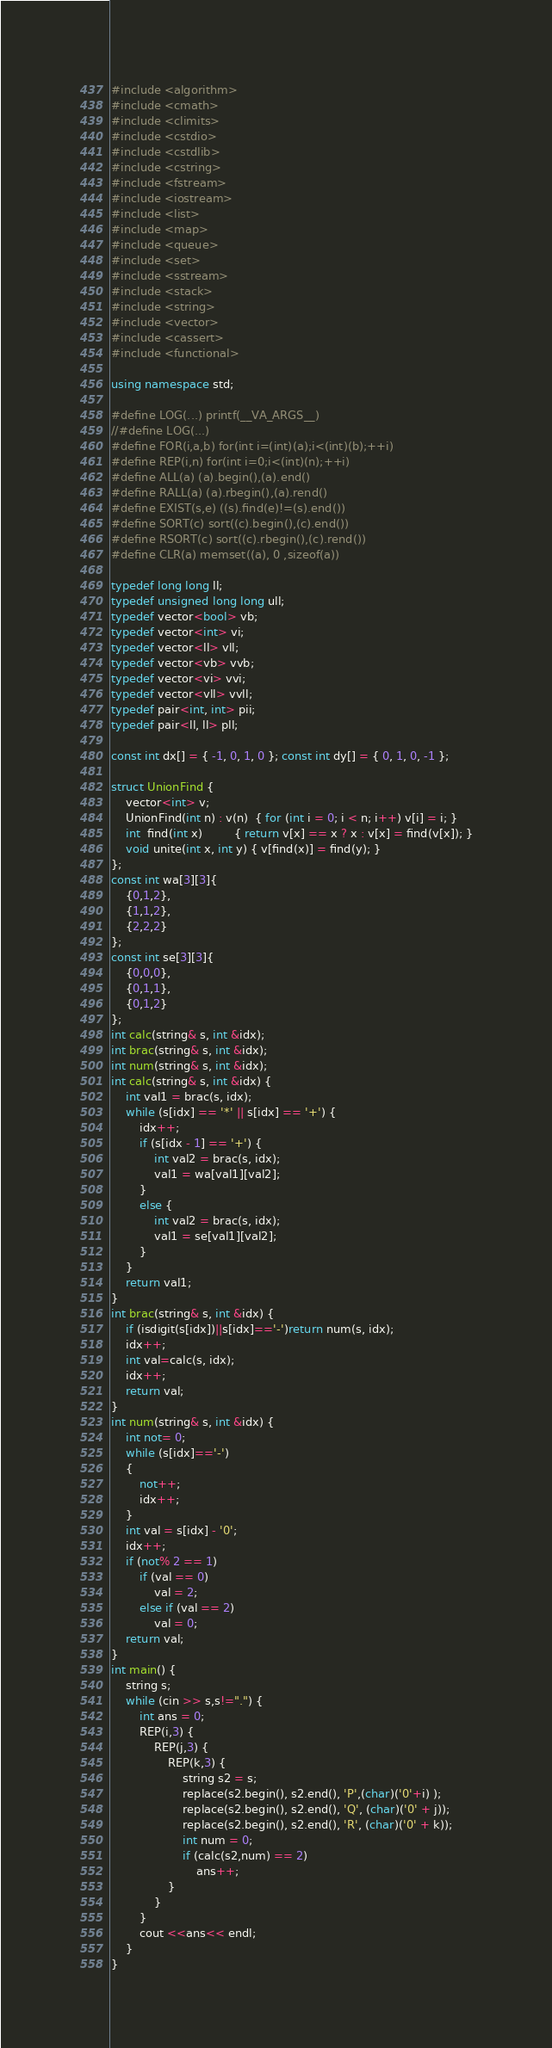<code> <loc_0><loc_0><loc_500><loc_500><_C++_>#include <algorithm>
#include <cmath>
#include <climits>
#include <cstdio>
#include <cstdlib>
#include <cstring>
#include <fstream>
#include <iostream>
#include <list>
#include <map>
#include <queue>
#include <set>
#include <sstream>
#include <stack>
#include <string>
#include <vector>
#include <cassert>
#include <functional>

using namespace std;

#define LOG(...) printf(__VA_ARGS__)
//#define LOG(...)
#define FOR(i,a,b) for(int i=(int)(a);i<(int)(b);++i)
#define REP(i,n) for(int i=0;i<(int)(n);++i)
#define ALL(a) (a).begin(),(a).end()
#define RALL(a) (a).rbegin(),(a).rend()
#define EXIST(s,e) ((s).find(e)!=(s).end())
#define SORT(c) sort((c).begin(),(c).end())
#define RSORT(c) sort((c).rbegin(),(c).rend())
#define CLR(a) memset((a), 0 ,sizeof(a))

typedef long long ll;
typedef unsigned long long ull;
typedef vector<bool> vb;
typedef vector<int> vi;
typedef vector<ll> vll;
typedef vector<vb> vvb;
typedef vector<vi> vvi;
typedef vector<vll> vvll;
typedef pair<int, int> pii;
typedef pair<ll, ll> pll;

const int dx[] = { -1, 0, 1, 0 }; const int dy[] = { 0, 1, 0, -1 };

struct UnionFind {
	vector<int> v;
	UnionFind(int n) : v(n)  { for (int i = 0; i < n; i++) v[i] = i; }
	int  find(int x)         { return v[x] == x ? x : v[x] = find(v[x]); }
	void unite(int x, int y) { v[find(x)] = find(y); }
};
const int wa[3][3]{
	{0,1,2},
	{1,1,2},
	{2,2,2}
};
const int se[3][3]{
	{0,0,0},
	{0,1,1},
	{0,1,2}
};
int calc(string& s, int &idx);
int brac(string& s, int &idx);
int num(string& s, int &idx);
int calc(string& s, int &idx) {
	int val1 = brac(s, idx);
	while (s[idx] == '*' || s[idx] == '+') {
		idx++;
		if (s[idx - 1] == '+') {
			int val2 = brac(s, idx);
			val1 = wa[val1][val2];
		}
		else {
			int val2 = brac(s, idx);
			val1 = se[val1][val2];
		}
	}
	return val1;
}
int brac(string& s, int &idx) {
	if (isdigit(s[idx])||s[idx]=='-')return num(s, idx);
	idx++;
	int val=calc(s, idx);
	idx++;
	return val;
}
int num(string& s, int &idx) {
	int not= 0;
	while (s[idx]=='-')
	{
		not++;
		idx++;
	}
	int val = s[idx] - '0';
	idx++;
	if (not% 2 == 1)
		if (val == 0)
			val = 2;
		else if (val == 2)
			val = 0;
	return val;
}
int main() {
	string s;
	while (cin >> s,s!=".") {
		int ans = 0;
		REP(i,3) {
			REP(j,3) {
				REP(k,3) {
					string s2 = s;
					replace(s2.begin(), s2.end(), 'P',(char)('0'+i) );
					replace(s2.begin(), s2.end(), 'Q', (char)('0' + j));
					replace(s2.begin(), s2.end(), 'R', (char)('0' + k));
					int num = 0;
					if (calc(s2,num) == 2)
						ans++;
				}
			}
		}
		cout <<ans<< endl;
	}
}</code> 